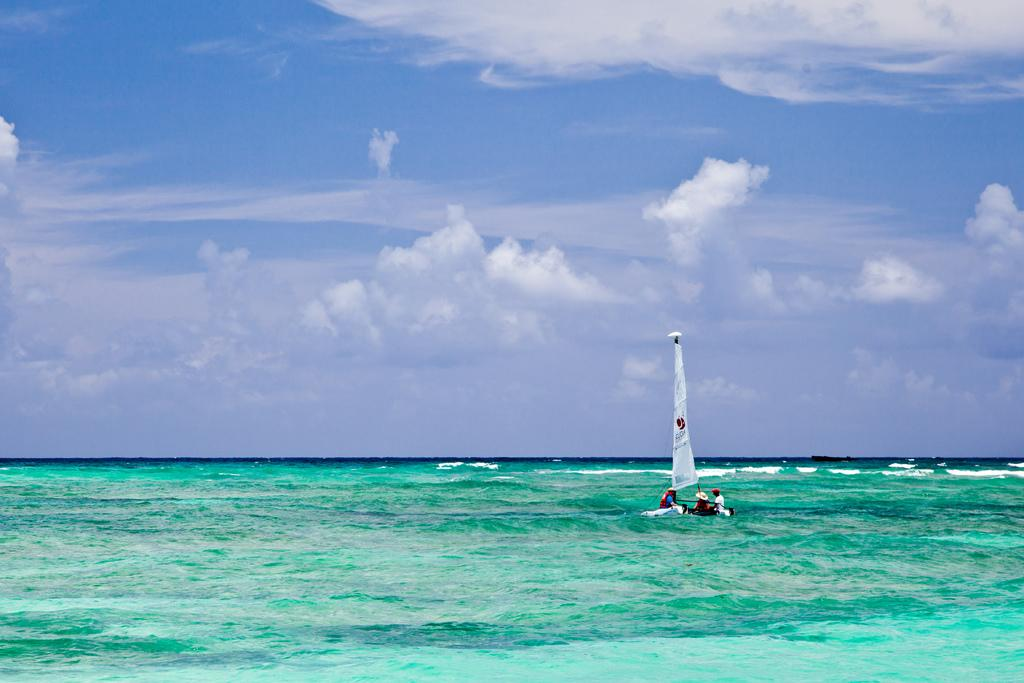What is the main subject of the image? The main subject of the image is a boat. Where is the boat located? The boat is on the water. How many people are on the boat? There are three people sitting on the boat. What can be seen in the background of the image? The sky is visible in the background of the image. What is the condition of the sky in the image? Clouds are present in the sky. What type of friction can be seen between the boat and the water in the image? There is no specific type of friction visible between the boat and the water in the image. What does the mom of the people on the boat look like? There is no information about the mom of the people on the boat in the image. 